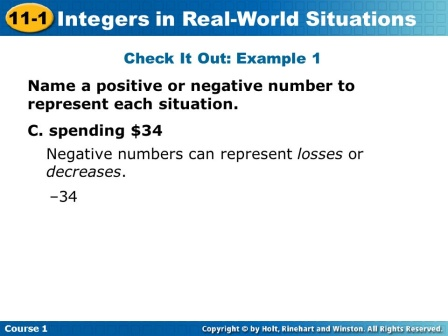What are the key elements in this picture? The image shows a slide from a mathematics lesson focused on integers, practically explaining how positive and negative numbers can represent real-world situations. The key elements include:

1. **Title and Theme:** The headline in a blue bar at the top reads 'Integers in Real-World Situations', clearly portraying the theme. The slide is part of Section 11-1.
2. **Instructional Text:** Below the headline, instructions are provided under 'Check It Out: Example 1', directing students to 'Name a positive or negative number to represent each situation'.
3. **Example Scenario:** A specific example “C. spending $34” is given.
4. **Answer:** The answer “-34” is displayed in red to highlight it, indicating that spending money can be represented by a negative number.
5. **Guiding Note:** At the bottom, an additional note explains that 'Negative numbers can represent losses or decreases,' reinforcing the practical application of negative integers. 